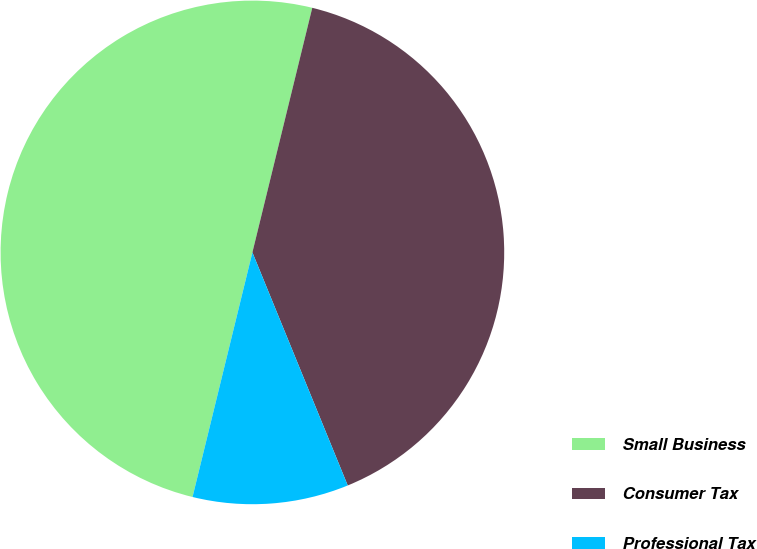Convert chart to OTSL. <chart><loc_0><loc_0><loc_500><loc_500><pie_chart><fcel>Small Business<fcel>Consumer Tax<fcel>Professional Tax<nl><fcel>50.0%<fcel>40.0%<fcel>10.0%<nl></chart> 